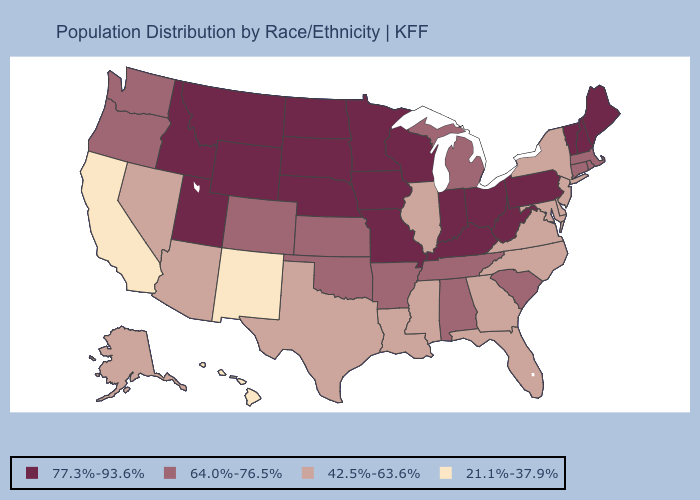Does the first symbol in the legend represent the smallest category?
Concise answer only. No. Does Oregon have a higher value than Illinois?
Quick response, please. Yes. What is the lowest value in the MidWest?
Quick response, please. 42.5%-63.6%. Name the states that have a value in the range 64.0%-76.5%?
Concise answer only. Alabama, Arkansas, Colorado, Connecticut, Kansas, Massachusetts, Michigan, Oklahoma, Oregon, Rhode Island, South Carolina, Tennessee, Washington. Name the states that have a value in the range 42.5%-63.6%?
Write a very short answer. Alaska, Arizona, Delaware, Florida, Georgia, Illinois, Louisiana, Maryland, Mississippi, Nevada, New Jersey, New York, North Carolina, Texas, Virginia. What is the value of Tennessee?
Quick response, please. 64.0%-76.5%. Which states have the lowest value in the MidWest?
Be succinct. Illinois. What is the value of Arkansas?
Answer briefly. 64.0%-76.5%. What is the value of North Carolina?
Quick response, please. 42.5%-63.6%. Does Hawaii have the highest value in the West?
Be succinct. No. Does Virginia have a higher value than Kentucky?
Give a very brief answer. No. What is the value of Iowa?
Give a very brief answer. 77.3%-93.6%. Does Idaho have the highest value in the USA?
Write a very short answer. Yes. What is the value of Delaware?
Quick response, please. 42.5%-63.6%. 